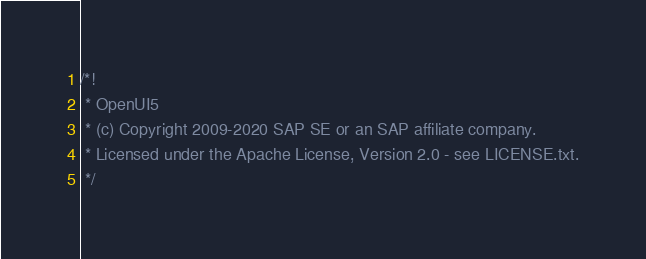<code> <loc_0><loc_0><loc_500><loc_500><_JavaScript_>/*!
 * OpenUI5
 * (c) Copyright 2009-2020 SAP SE or an SAP affiliate company.
 * Licensed under the Apache License, Version 2.0 - see LICENSE.txt.
 */</code> 